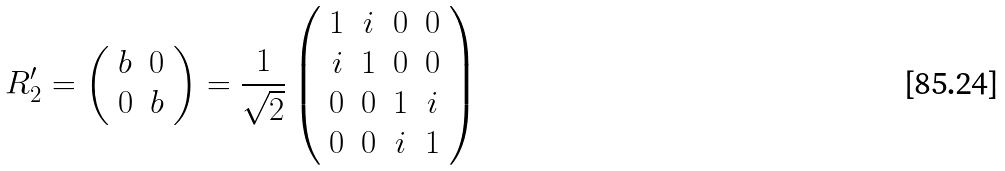Convert formula to latex. <formula><loc_0><loc_0><loc_500><loc_500>R _ { 2 } ^ { \prime } = \left ( \begin{array} { c c } b & 0 \\ 0 & b \end{array} \right ) = \frac { 1 } { \sqrt { 2 } } \left ( \begin{array} { c c c c } 1 & i & 0 & 0 \\ i & 1 & 0 & 0 \\ 0 & 0 & 1 & i \\ 0 & 0 & i & 1 \end{array} \right )</formula> 